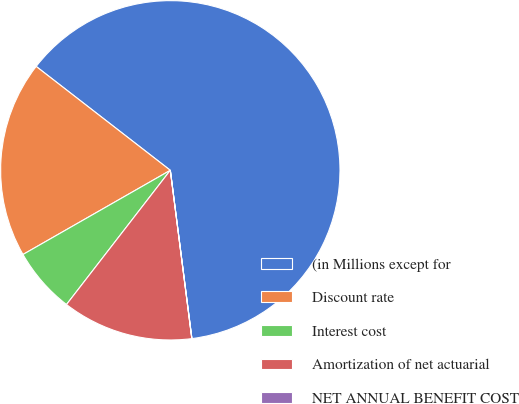Convert chart. <chart><loc_0><loc_0><loc_500><loc_500><pie_chart><fcel>(in Millions except for<fcel>Discount rate<fcel>Interest cost<fcel>Amortization of net actuarial<fcel>NET ANNUAL BENEFIT COST<nl><fcel>62.48%<fcel>18.75%<fcel>6.26%<fcel>12.5%<fcel>0.01%<nl></chart> 